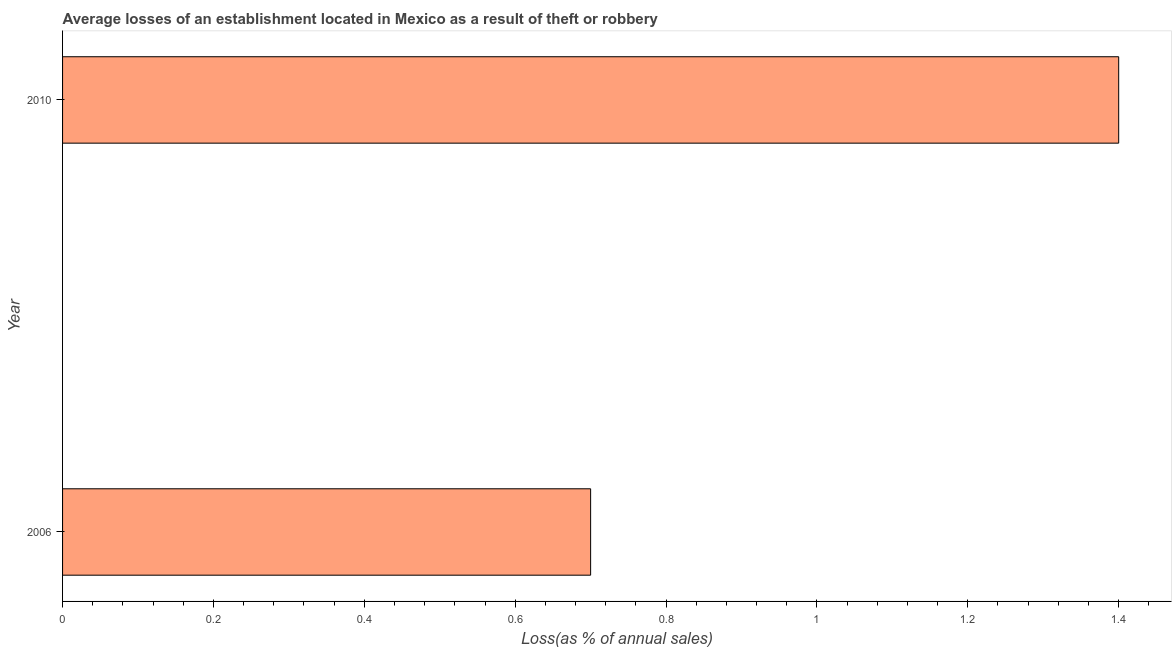What is the title of the graph?
Your answer should be very brief. Average losses of an establishment located in Mexico as a result of theft or robbery. What is the label or title of the X-axis?
Ensure brevity in your answer.  Loss(as % of annual sales). What is the label or title of the Y-axis?
Keep it short and to the point. Year. What is the losses due to theft in 2006?
Offer a very short reply. 0.7. Across all years, what is the maximum losses due to theft?
Make the answer very short. 1.4. What is the sum of the losses due to theft?
Your answer should be compact. 2.1. What is the median losses due to theft?
Offer a very short reply. 1.05. Is the losses due to theft in 2006 less than that in 2010?
Provide a short and direct response. Yes. How many years are there in the graph?
Your answer should be compact. 2. What is the Loss(as % of annual sales) of 2010?
Provide a short and direct response. 1.4. What is the difference between the Loss(as % of annual sales) in 2006 and 2010?
Provide a succinct answer. -0.7. What is the ratio of the Loss(as % of annual sales) in 2006 to that in 2010?
Provide a succinct answer. 0.5. 